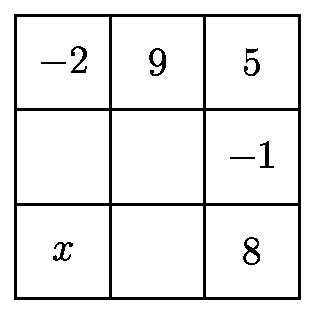Can this type of puzzle be solved with different solutions, or is there typically only one correct answer? This type of puzzle typically has a unique solution, especially when a condition is given that one of the missing numbers is larger than the others. By adhering to the condition that the sums of the numbers in each row and column must be equal and using logical deduction, you can arrive at the single correct set of missing numbers that completes the puzzle correctly. 